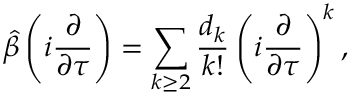<formula> <loc_0><loc_0><loc_500><loc_500>\hat { \beta } \left ( i \frac { \partial } { \partial \tau } \right ) = \sum _ { k \geq 2 } \frac { d _ { k } } { k ! } \left ( i \frac { \partial } { \partial \tau } \right ) ^ { k } ,</formula> 